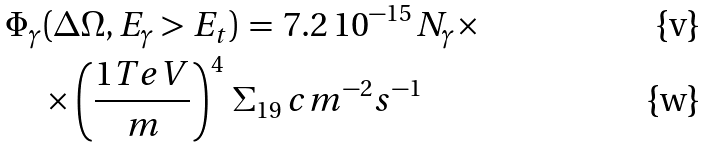Convert formula to latex. <formula><loc_0><loc_0><loc_500><loc_500>& \Phi _ { \gamma } ( \Delta \Omega , E _ { \gamma } > E _ { t } ) \, = \, 7 . 2 \, 1 0 ^ { - 1 5 } \, N _ { \gamma } \times \\ & \quad \times \left ( \frac { 1 T e V } { m } \right ) ^ { 4 } \, \Sigma _ { 1 9 } \, c m ^ { - 2 } s ^ { - 1 }</formula> 